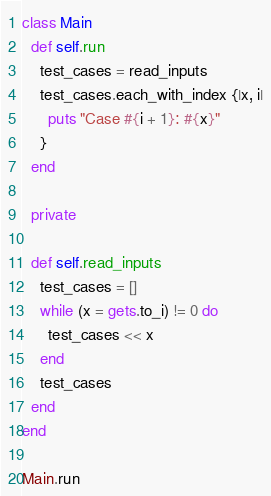Convert code to text. <code><loc_0><loc_0><loc_500><loc_500><_Ruby_>class Main
  def self.run
    test_cases = read_inputs
    test_cases.each_with_index {|x, i|
      puts "Case #{i + 1}: #{x}"
    }
  end

  private

  def self.read_inputs
    test_cases = []
    while (x = gets.to_i) != 0 do
      test_cases << x
    end
    test_cases
  end
end

Main.run</code> 